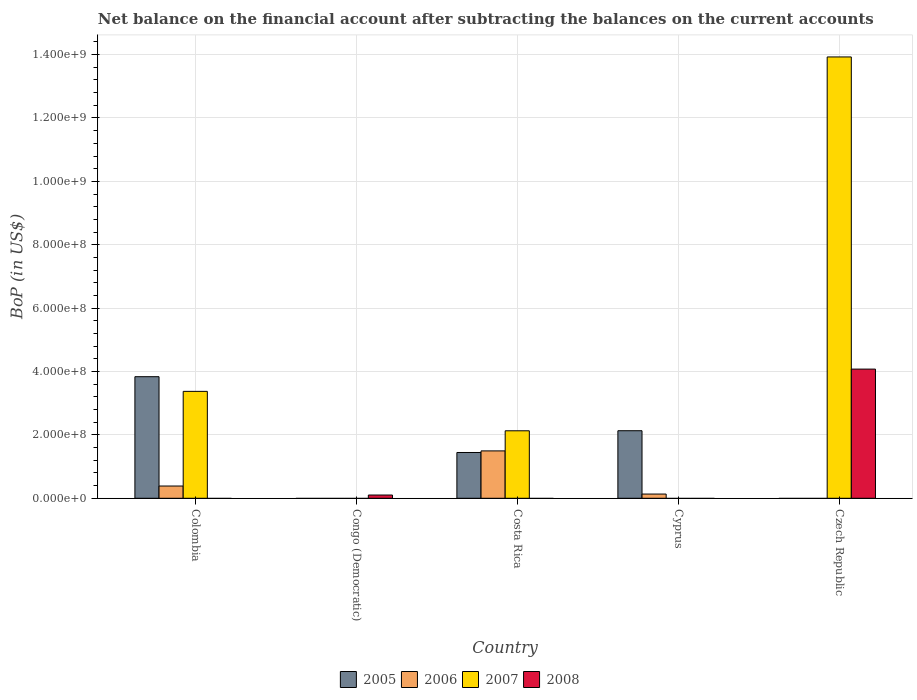How many different coloured bars are there?
Your answer should be compact. 4. Are the number of bars per tick equal to the number of legend labels?
Make the answer very short. No. Are the number of bars on each tick of the X-axis equal?
Provide a short and direct response. No. What is the label of the 5th group of bars from the left?
Your answer should be very brief. Czech Republic. Across all countries, what is the maximum Balance of Payments in 2007?
Your response must be concise. 1.39e+09. Across all countries, what is the minimum Balance of Payments in 2008?
Ensure brevity in your answer.  0. In which country was the Balance of Payments in 2005 maximum?
Offer a very short reply. Colombia. What is the total Balance of Payments in 2008 in the graph?
Give a very brief answer. 4.18e+08. What is the difference between the Balance of Payments in 2006 in Costa Rica and that in Cyprus?
Ensure brevity in your answer.  1.36e+08. What is the difference between the Balance of Payments in 2008 in Cyprus and the Balance of Payments in 2006 in Colombia?
Provide a short and direct response. -3.87e+07. What is the average Balance of Payments in 2005 per country?
Offer a terse response. 1.48e+08. What is the difference between the Balance of Payments of/in 2006 and Balance of Payments of/in 2005 in Cyprus?
Give a very brief answer. -2.00e+08. In how many countries, is the Balance of Payments in 2005 greater than 1080000000 US$?
Your response must be concise. 0. What is the ratio of the Balance of Payments in 2007 in Colombia to that in Czech Republic?
Your answer should be compact. 0.24. Is the Balance of Payments in 2008 in Congo (Democratic) less than that in Czech Republic?
Your answer should be very brief. Yes. What is the difference between the highest and the second highest Balance of Payments in 2005?
Provide a succinct answer. -6.87e+07. What is the difference between the highest and the lowest Balance of Payments in 2007?
Keep it short and to the point. 1.39e+09. Is the sum of the Balance of Payments in 2005 in Colombia and Cyprus greater than the maximum Balance of Payments in 2008 across all countries?
Your response must be concise. Yes. Is it the case that in every country, the sum of the Balance of Payments in 2006 and Balance of Payments in 2007 is greater than the Balance of Payments in 2005?
Keep it short and to the point. No. How many bars are there?
Ensure brevity in your answer.  11. Are all the bars in the graph horizontal?
Your answer should be very brief. No. How many countries are there in the graph?
Offer a terse response. 5. What is the difference between two consecutive major ticks on the Y-axis?
Offer a very short reply. 2.00e+08. Does the graph contain grids?
Your answer should be very brief. Yes. Where does the legend appear in the graph?
Your response must be concise. Bottom center. What is the title of the graph?
Make the answer very short. Net balance on the financial account after subtracting the balances on the current accounts. Does "2000" appear as one of the legend labels in the graph?
Keep it short and to the point. No. What is the label or title of the X-axis?
Provide a short and direct response. Country. What is the label or title of the Y-axis?
Give a very brief answer. BoP (in US$). What is the BoP (in US$) of 2005 in Colombia?
Your answer should be compact. 3.84e+08. What is the BoP (in US$) in 2006 in Colombia?
Provide a short and direct response. 3.87e+07. What is the BoP (in US$) of 2007 in Colombia?
Your answer should be compact. 3.37e+08. What is the BoP (in US$) in 2008 in Colombia?
Provide a short and direct response. 0. What is the BoP (in US$) of 2005 in Congo (Democratic)?
Ensure brevity in your answer.  0. What is the BoP (in US$) of 2007 in Congo (Democratic)?
Make the answer very short. 0. What is the BoP (in US$) of 2008 in Congo (Democratic)?
Provide a succinct answer. 1.03e+07. What is the BoP (in US$) of 2005 in Costa Rica?
Make the answer very short. 1.44e+08. What is the BoP (in US$) in 2006 in Costa Rica?
Your response must be concise. 1.50e+08. What is the BoP (in US$) of 2007 in Costa Rica?
Ensure brevity in your answer.  2.13e+08. What is the BoP (in US$) of 2008 in Costa Rica?
Give a very brief answer. 0. What is the BoP (in US$) in 2005 in Cyprus?
Provide a succinct answer. 2.13e+08. What is the BoP (in US$) in 2006 in Cyprus?
Give a very brief answer. 1.33e+07. What is the BoP (in US$) of 2007 in Cyprus?
Your response must be concise. 0. What is the BoP (in US$) of 2008 in Cyprus?
Your response must be concise. 0. What is the BoP (in US$) in 2007 in Czech Republic?
Offer a terse response. 1.39e+09. What is the BoP (in US$) in 2008 in Czech Republic?
Offer a very short reply. 4.08e+08. Across all countries, what is the maximum BoP (in US$) of 2005?
Your response must be concise. 3.84e+08. Across all countries, what is the maximum BoP (in US$) of 2006?
Your response must be concise. 1.50e+08. Across all countries, what is the maximum BoP (in US$) in 2007?
Your response must be concise. 1.39e+09. Across all countries, what is the maximum BoP (in US$) of 2008?
Provide a succinct answer. 4.08e+08. Across all countries, what is the minimum BoP (in US$) of 2006?
Keep it short and to the point. 0. Across all countries, what is the minimum BoP (in US$) of 2007?
Your response must be concise. 0. Across all countries, what is the minimum BoP (in US$) of 2008?
Make the answer very short. 0. What is the total BoP (in US$) of 2005 in the graph?
Your answer should be compact. 7.41e+08. What is the total BoP (in US$) of 2006 in the graph?
Keep it short and to the point. 2.02e+08. What is the total BoP (in US$) in 2007 in the graph?
Your answer should be very brief. 1.94e+09. What is the total BoP (in US$) in 2008 in the graph?
Provide a short and direct response. 4.18e+08. What is the difference between the BoP (in US$) of 2005 in Colombia and that in Costa Rica?
Provide a succinct answer. 2.39e+08. What is the difference between the BoP (in US$) in 2006 in Colombia and that in Costa Rica?
Offer a very short reply. -1.11e+08. What is the difference between the BoP (in US$) in 2007 in Colombia and that in Costa Rica?
Offer a terse response. 1.24e+08. What is the difference between the BoP (in US$) of 2005 in Colombia and that in Cyprus?
Give a very brief answer. 1.70e+08. What is the difference between the BoP (in US$) of 2006 in Colombia and that in Cyprus?
Keep it short and to the point. 2.53e+07. What is the difference between the BoP (in US$) in 2007 in Colombia and that in Czech Republic?
Your response must be concise. -1.06e+09. What is the difference between the BoP (in US$) of 2008 in Congo (Democratic) and that in Czech Republic?
Your answer should be very brief. -3.97e+08. What is the difference between the BoP (in US$) in 2005 in Costa Rica and that in Cyprus?
Offer a terse response. -6.87e+07. What is the difference between the BoP (in US$) in 2006 in Costa Rica and that in Cyprus?
Give a very brief answer. 1.36e+08. What is the difference between the BoP (in US$) of 2007 in Costa Rica and that in Czech Republic?
Offer a terse response. -1.18e+09. What is the difference between the BoP (in US$) in 2005 in Colombia and the BoP (in US$) in 2008 in Congo (Democratic)?
Your answer should be compact. 3.73e+08. What is the difference between the BoP (in US$) of 2006 in Colombia and the BoP (in US$) of 2008 in Congo (Democratic)?
Provide a short and direct response. 2.84e+07. What is the difference between the BoP (in US$) of 2007 in Colombia and the BoP (in US$) of 2008 in Congo (Democratic)?
Your answer should be compact. 3.27e+08. What is the difference between the BoP (in US$) of 2005 in Colombia and the BoP (in US$) of 2006 in Costa Rica?
Offer a very short reply. 2.34e+08. What is the difference between the BoP (in US$) in 2005 in Colombia and the BoP (in US$) in 2007 in Costa Rica?
Offer a terse response. 1.71e+08. What is the difference between the BoP (in US$) in 2006 in Colombia and the BoP (in US$) in 2007 in Costa Rica?
Offer a very short reply. -1.74e+08. What is the difference between the BoP (in US$) in 2005 in Colombia and the BoP (in US$) in 2006 in Cyprus?
Offer a terse response. 3.70e+08. What is the difference between the BoP (in US$) in 2005 in Colombia and the BoP (in US$) in 2007 in Czech Republic?
Your answer should be compact. -1.01e+09. What is the difference between the BoP (in US$) of 2005 in Colombia and the BoP (in US$) of 2008 in Czech Republic?
Your answer should be compact. -2.39e+07. What is the difference between the BoP (in US$) of 2006 in Colombia and the BoP (in US$) of 2007 in Czech Republic?
Offer a terse response. -1.35e+09. What is the difference between the BoP (in US$) of 2006 in Colombia and the BoP (in US$) of 2008 in Czech Republic?
Your answer should be very brief. -3.69e+08. What is the difference between the BoP (in US$) in 2007 in Colombia and the BoP (in US$) in 2008 in Czech Republic?
Provide a succinct answer. -7.03e+07. What is the difference between the BoP (in US$) in 2005 in Costa Rica and the BoP (in US$) in 2006 in Cyprus?
Keep it short and to the point. 1.31e+08. What is the difference between the BoP (in US$) of 2005 in Costa Rica and the BoP (in US$) of 2007 in Czech Republic?
Make the answer very short. -1.25e+09. What is the difference between the BoP (in US$) of 2005 in Costa Rica and the BoP (in US$) of 2008 in Czech Republic?
Offer a terse response. -2.63e+08. What is the difference between the BoP (in US$) of 2006 in Costa Rica and the BoP (in US$) of 2007 in Czech Republic?
Ensure brevity in your answer.  -1.24e+09. What is the difference between the BoP (in US$) in 2006 in Costa Rica and the BoP (in US$) in 2008 in Czech Republic?
Provide a short and direct response. -2.58e+08. What is the difference between the BoP (in US$) of 2007 in Costa Rica and the BoP (in US$) of 2008 in Czech Republic?
Provide a succinct answer. -1.95e+08. What is the difference between the BoP (in US$) of 2005 in Cyprus and the BoP (in US$) of 2007 in Czech Republic?
Make the answer very short. -1.18e+09. What is the difference between the BoP (in US$) in 2005 in Cyprus and the BoP (in US$) in 2008 in Czech Republic?
Offer a very short reply. -1.94e+08. What is the difference between the BoP (in US$) in 2006 in Cyprus and the BoP (in US$) in 2007 in Czech Republic?
Provide a short and direct response. -1.38e+09. What is the difference between the BoP (in US$) of 2006 in Cyprus and the BoP (in US$) of 2008 in Czech Republic?
Offer a terse response. -3.94e+08. What is the average BoP (in US$) in 2005 per country?
Offer a very short reply. 1.48e+08. What is the average BoP (in US$) of 2006 per country?
Offer a terse response. 4.03e+07. What is the average BoP (in US$) of 2007 per country?
Your answer should be very brief. 3.89e+08. What is the average BoP (in US$) in 2008 per country?
Give a very brief answer. 8.36e+07. What is the difference between the BoP (in US$) of 2005 and BoP (in US$) of 2006 in Colombia?
Your answer should be compact. 3.45e+08. What is the difference between the BoP (in US$) in 2005 and BoP (in US$) in 2007 in Colombia?
Keep it short and to the point. 4.63e+07. What is the difference between the BoP (in US$) of 2006 and BoP (in US$) of 2007 in Colombia?
Keep it short and to the point. -2.99e+08. What is the difference between the BoP (in US$) in 2005 and BoP (in US$) in 2006 in Costa Rica?
Provide a short and direct response. -5.05e+06. What is the difference between the BoP (in US$) of 2005 and BoP (in US$) of 2007 in Costa Rica?
Offer a very short reply. -6.85e+07. What is the difference between the BoP (in US$) of 2006 and BoP (in US$) of 2007 in Costa Rica?
Ensure brevity in your answer.  -6.34e+07. What is the difference between the BoP (in US$) of 2005 and BoP (in US$) of 2006 in Cyprus?
Your answer should be compact. 2.00e+08. What is the difference between the BoP (in US$) in 2007 and BoP (in US$) in 2008 in Czech Republic?
Give a very brief answer. 9.85e+08. What is the ratio of the BoP (in US$) in 2005 in Colombia to that in Costa Rica?
Provide a succinct answer. 2.66. What is the ratio of the BoP (in US$) in 2006 in Colombia to that in Costa Rica?
Your answer should be compact. 0.26. What is the ratio of the BoP (in US$) of 2007 in Colombia to that in Costa Rica?
Your answer should be very brief. 1.58. What is the ratio of the BoP (in US$) of 2005 in Colombia to that in Cyprus?
Your response must be concise. 1.8. What is the ratio of the BoP (in US$) in 2006 in Colombia to that in Cyprus?
Make the answer very short. 2.9. What is the ratio of the BoP (in US$) in 2007 in Colombia to that in Czech Republic?
Offer a very short reply. 0.24. What is the ratio of the BoP (in US$) of 2008 in Congo (Democratic) to that in Czech Republic?
Give a very brief answer. 0.03. What is the ratio of the BoP (in US$) of 2005 in Costa Rica to that in Cyprus?
Provide a succinct answer. 0.68. What is the ratio of the BoP (in US$) of 2006 in Costa Rica to that in Cyprus?
Make the answer very short. 11.21. What is the ratio of the BoP (in US$) in 2007 in Costa Rica to that in Czech Republic?
Keep it short and to the point. 0.15. What is the difference between the highest and the second highest BoP (in US$) in 2005?
Ensure brevity in your answer.  1.70e+08. What is the difference between the highest and the second highest BoP (in US$) of 2006?
Provide a succinct answer. 1.11e+08. What is the difference between the highest and the second highest BoP (in US$) in 2007?
Your answer should be compact. 1.06e+09. What is the difference between the highest and the lowest BoP (in US$) of 2005?
Your answer should be compact. 3.84e+08. What is the difference between the highest and the lowest BoP (in US$) in 2006?
Ensure brevity in your answer.  1.50e+08. What is the difference between the highest and the lowest BoP (in US$) of 2007?
Make the answer very short. 1.39e+09. What is the difference between the highest and the lowest BoP (in US$) in 2008?
Make the answer very short. 4.08e+08. 